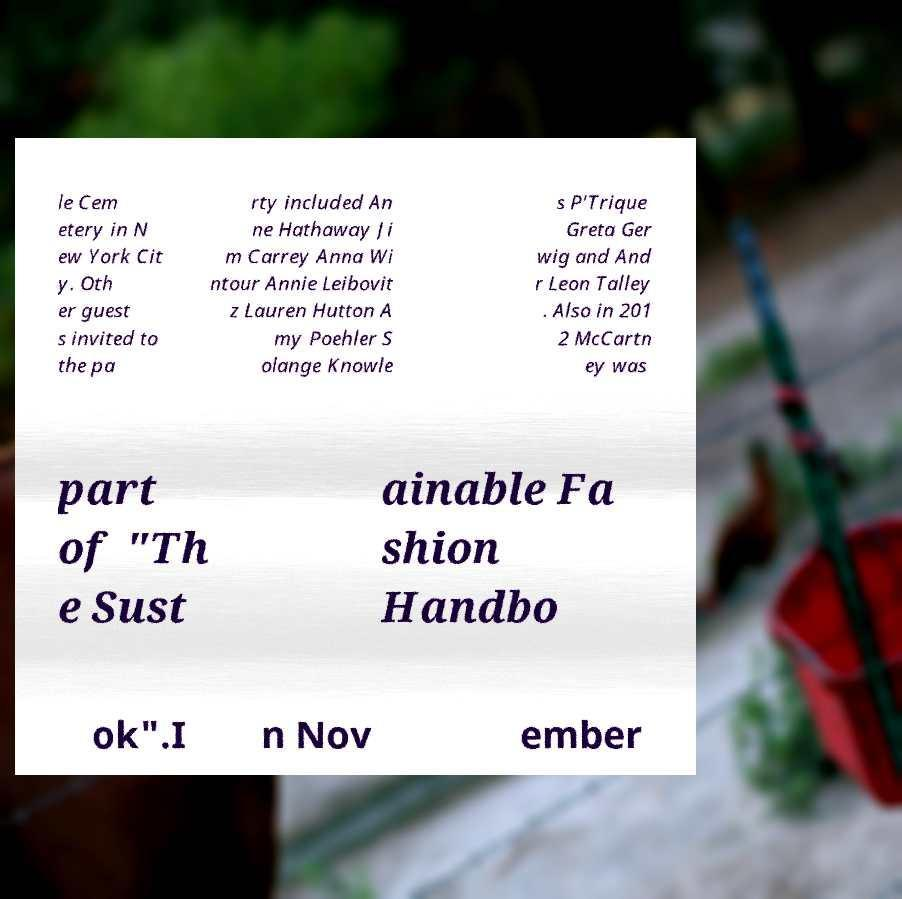I need the written content from this picture converted into text. Can you do that? le Cem etery in N ew York Cit y. Oth er guest s invited to the pa rty included An ne Hathaway Ji m Carrey Anna Wi ntour Annie Leibovit z Lauren Hutton A my Poehler S olange Knowle s P'Trique Greta Ger wig and And r Leon Talley . Also in 201 2 McCartn ey was part of "Th e Sust ainable Fa shion Handbo ok".I n Nov ember 